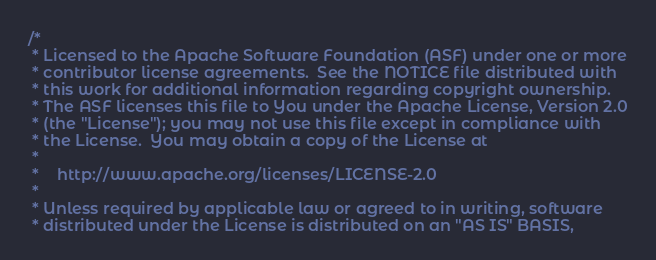Convert code to text. <code><loc_0><loc_0><loc_500><loc_500><_Scala_>/*
 * Licensed to the Apache Software Foundation (ASF) under one or more
 * contributor license agreements.  See the NOTICE file distributed with
 * this work for additional information regarding copyright ownership.
 * The ASF licenses this file to You under the Apache License, Version 2.0
 * (the "License"); you may not use this file except in compliance with
 * the License.  You may obtain a copy of the License at
 *
 *    http://www.apache.org/licenses/LICENSE-2.0
 *
 * Unless required by applicable law or agreed to in writing, software
 * distributed under the License is distributed on an "AS IS" BASIS,</code> 